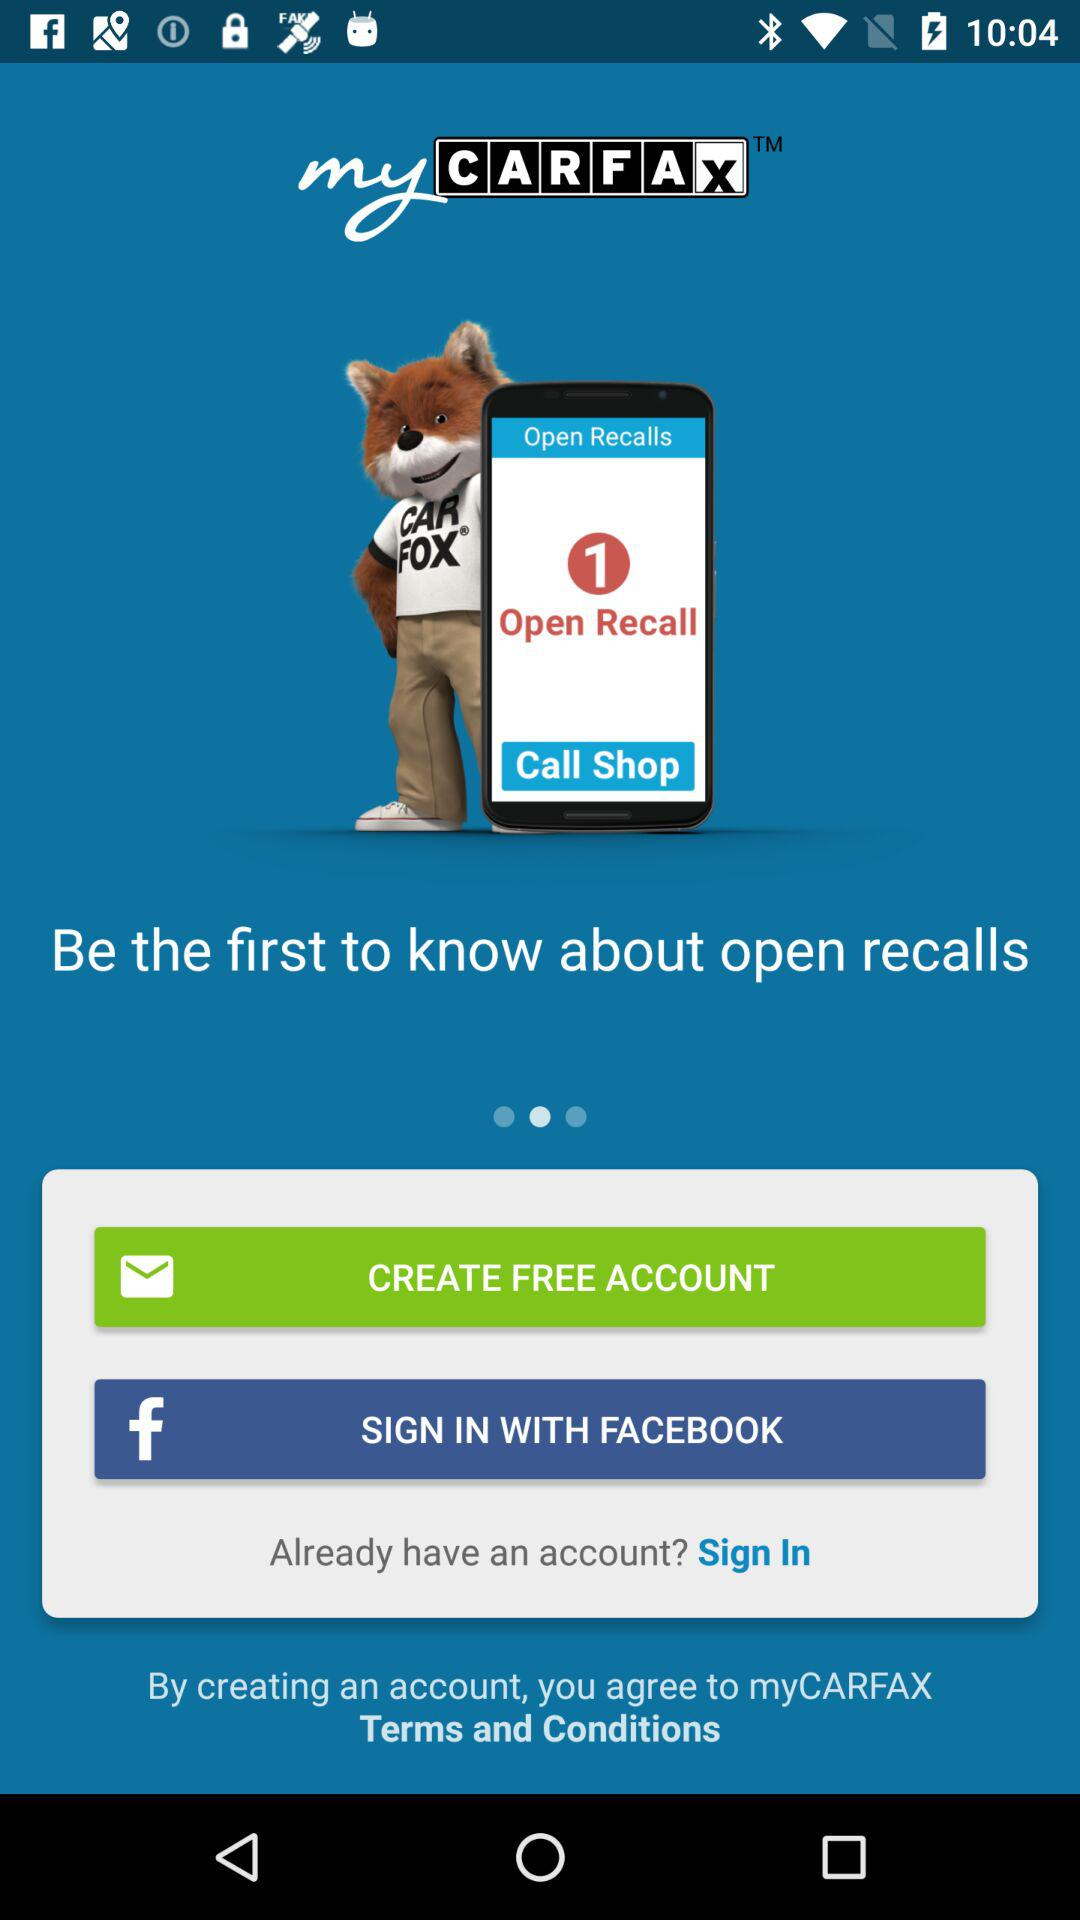What is the application name? The application name is "myCARFAX". 